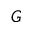<formula> <loc_0><loc_0><loc_500><loc_500>G</formula> 